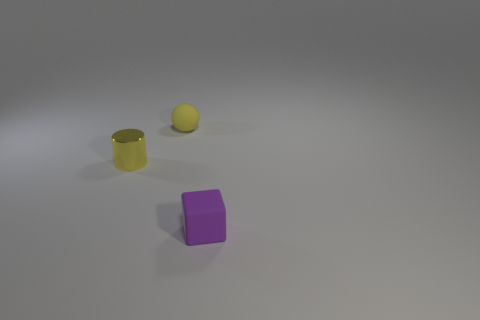Is the shape of the tiny purple rubber thing the same as the yellow matte thing? No, they are not the same shape. The purple object is a cube, having equal-length edges and right-angled corners, while the yellow object is a sphere, which is entirely round. 